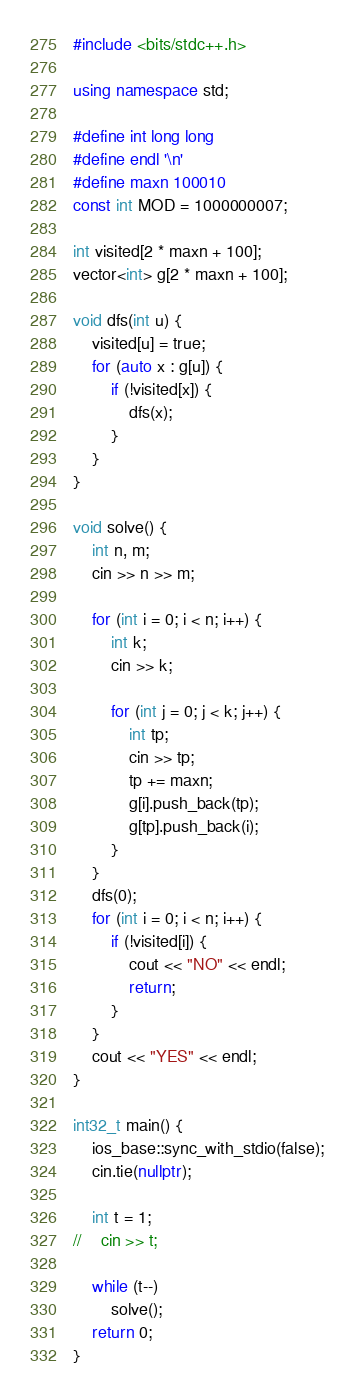Convert code to text. <code><loc_0><loc_0><loc_500><loc_500><_C++_>#include <bits/stdc++.h>

using namespace std;

#define int long long
#define endl '\n'
#define maxn 100010
const int MOD = 1000000007;

int visited[2 * maxn + 100];
vector<int> g[2 * maxn + 100];

void dfs(int u) {
    visited[u] = true;
    for (auto x : g[u]) {
        if (!visited[x]) {
            dfs(x);
        }
    }
}

void solve() {
    int n, m;
    cin >> n >> m;

    for (int i = 0; i < n; i++) {
        int k;
        cin >> k;

        for (int j = 0; j < k; j++) {
            int tp;
            cin >> tp;
            tp += maxn;
            g[i].push_back(tp);
            g[tp].push_back(i);
        }
    }
    dfs(0);
    for (int i = 0; i < n; i++) {
        if (!visited[i]) {
            cout << "NO" << endl;
            return;
        }
    }
    cout << "YES" << endl;
}

int32_t main() {
    ios_base::sync_with_stdio(false);
    cin.tie(nullptr);

    int t = 1;
//    cin >> t;

    while (t--)
        solve();
    return 0;
}</code> 